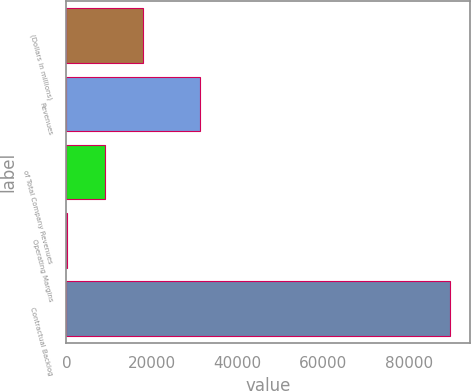Convert chart. <chart><loc_0><loc_0><loc_500><loc_500><bar_chart><fcel>(Dollars in millions)<fcel>Revenues<fcel>of Total Company Revenues<fcel>Operating Margins<fcel>Contractual Backlog<nl><fcel>17963<fcel>31171<fcel>8985.92<fcel>8.8<fcel>89780<nl></chart> 